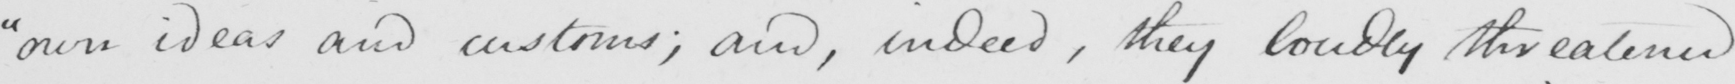What is written in this line of handwriting? " own ideas and customs ; and , indeed , they loudly threatened 